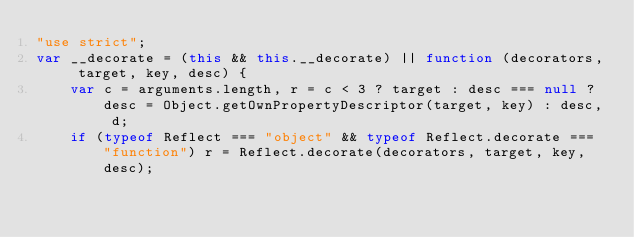Convert code to text. <code><loc_0><loc_0><loc_500><loc_500><_JavaScript_>"use strict";
var __decorate = (this && this.__decorate) || function (decorators, target, key, desc) {
    var c = arguments.length, r = c < 3 ? target : desc === null ? desc = Object.getOwnPropertyDescriptor(target, key) : desc, d;
    if (typeof Reflect === "object" && typeof Reflect.decorate === "function") r = Reflect.decorate(decorators, target, key, desc);</code> 